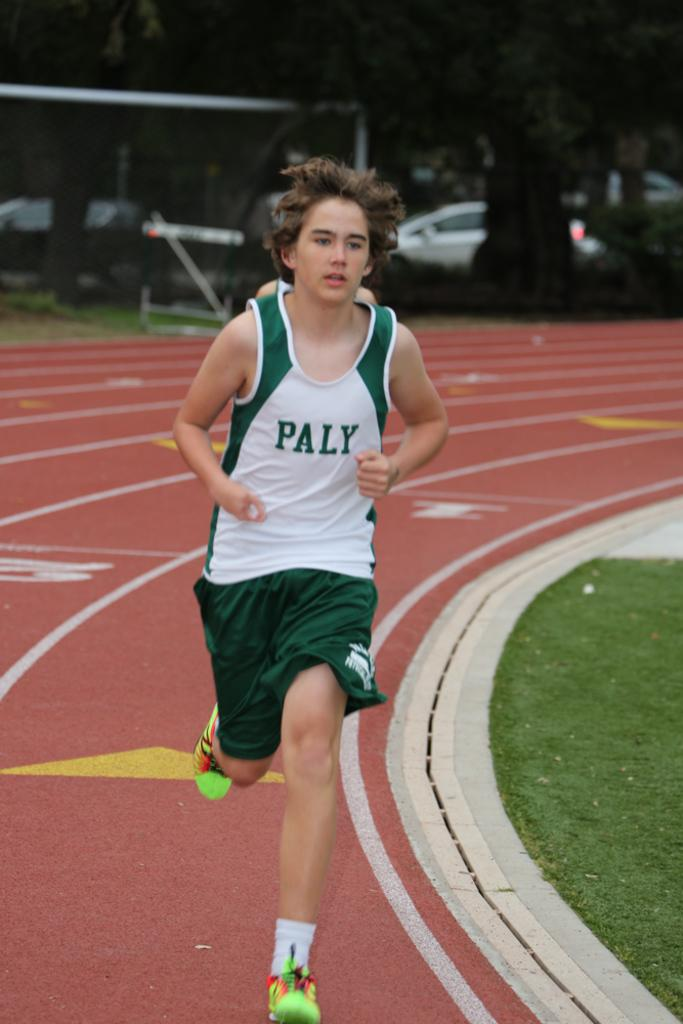<image>
Render a clear and concise summary of the photo. A male track runner running on the track wearing a green and white tank shirt with the word Paly across the front and green shorts. 